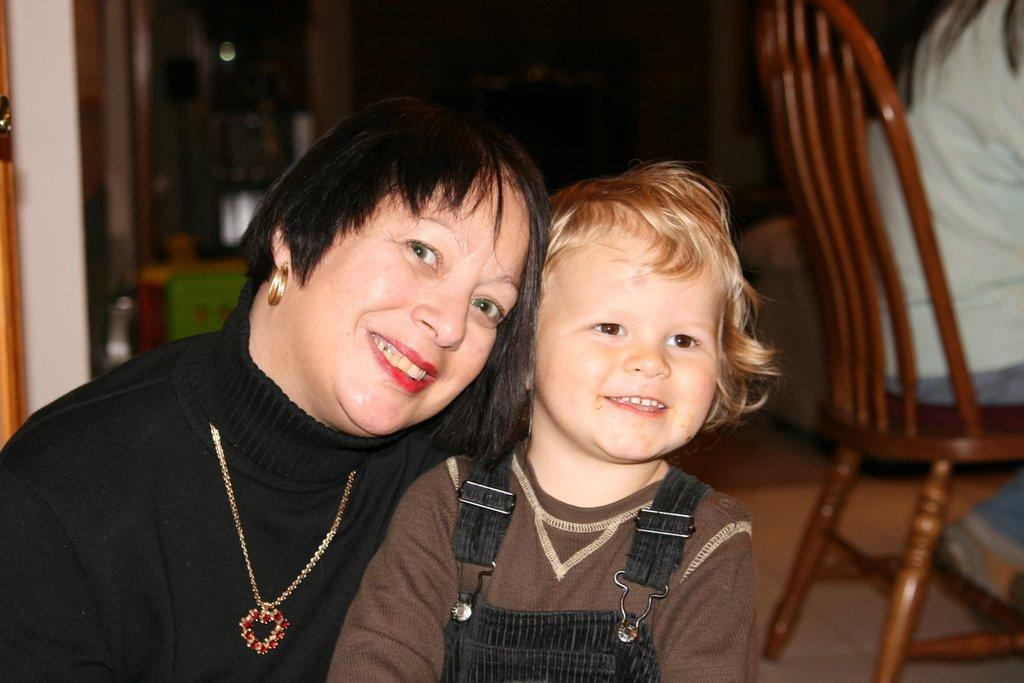How many people are in the image? There are two people in the image. What expressions do the people have? Both people are smiling. Can you describe the position of one of the people? There is a person sitting on a chair. What type of glove is the person wearing in the image? There is no glove visible in the image; both people are smiling and one is sitting on a chair. 